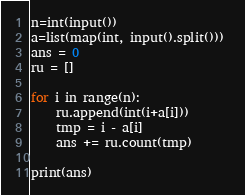<code> <loc_0><loc_0><loc_500><loc_500><_Python_>n=int(input())
a=list(map(int, input().split())) 
ans = 0
ru = []

for i in range(n):
    ru.append(int(i+a[i]))
    tmp = i - a[i]
    ans += ru.count(tmp)

print(ans)</code> 